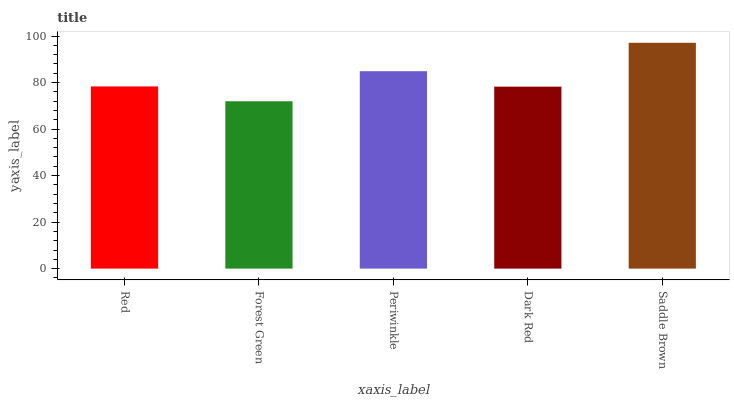Is Forest Green the minimum?
Answer yes or no. Yes. Is Saddle Brown the maximum?
Answer yes or no. Yes. Is Periwinkle the minimum?
Answer yes or no. No. Is Periwinkle the maximum?
Answer yes or no. No. Is Periwinkle greater than Forest Green?
Answer yes or no. Yes. Is Forest Green less than Periwinkle?
Answer yes or no. Yes. Is Forest Green greater than Periwinkle?
Answer yes or no. No. Is Periwinkle less than Forest Green?
Answer yes or no. No. Is Red the high median?
Answer yes or no. Yes. Is Red the low median?
Answer yes or no. Yes. Is Dark Red the high median?
Answer yes or no. No. Is Forest Green the low median?
Answer yes or no. No. 